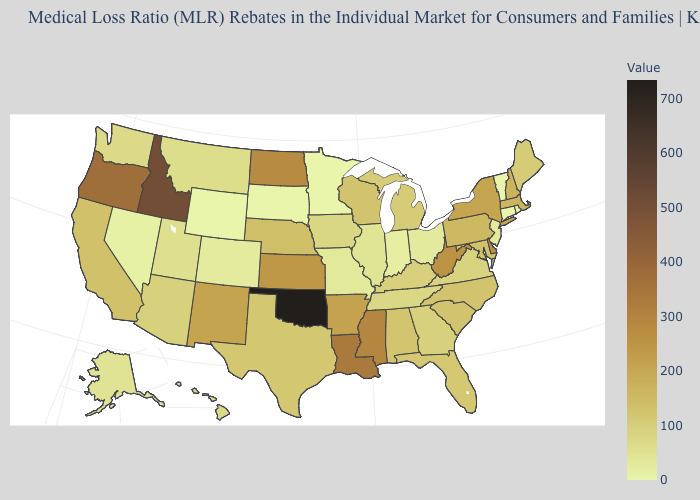Which states have the lowest value in the West?
Concise answer only. Wyoming. Among the states that border New York , does Massachusetts have the highest value?
Give a very brief answer. Yes. Among the states that border New York , which have the highest value?
Concise answer only. Massachusetts. Does Connecticut have the lowest value in the Northeast?
Write a very short answer. Yes. 